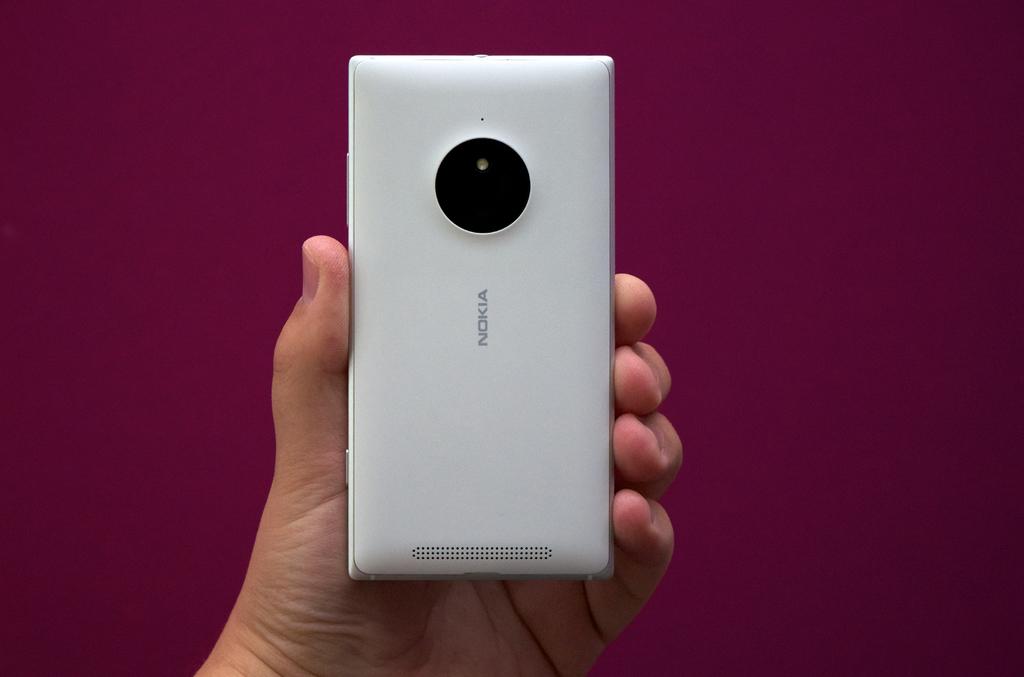Is that a marvel comic ?
Provide a succinct answer. No. 